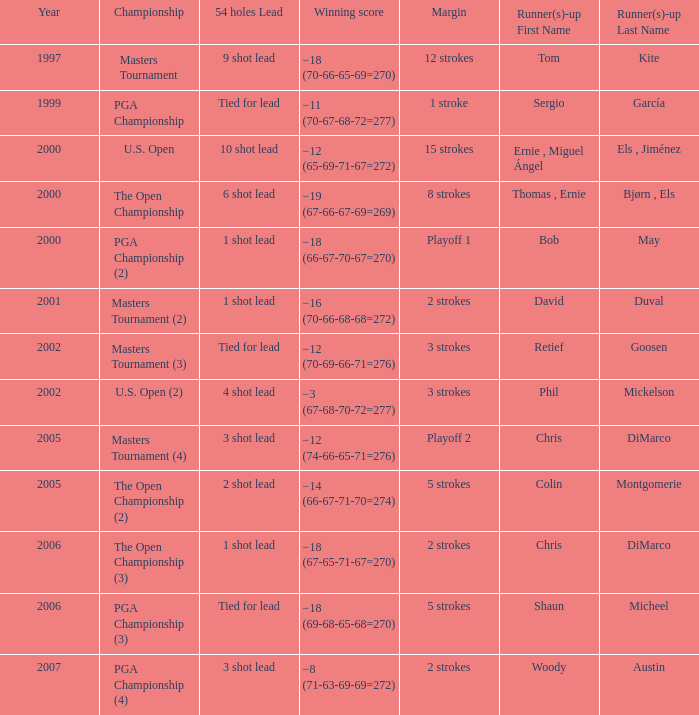 what's the championship where winning score is −12 (74-66-65-71=276) Masters Tournament (4). 